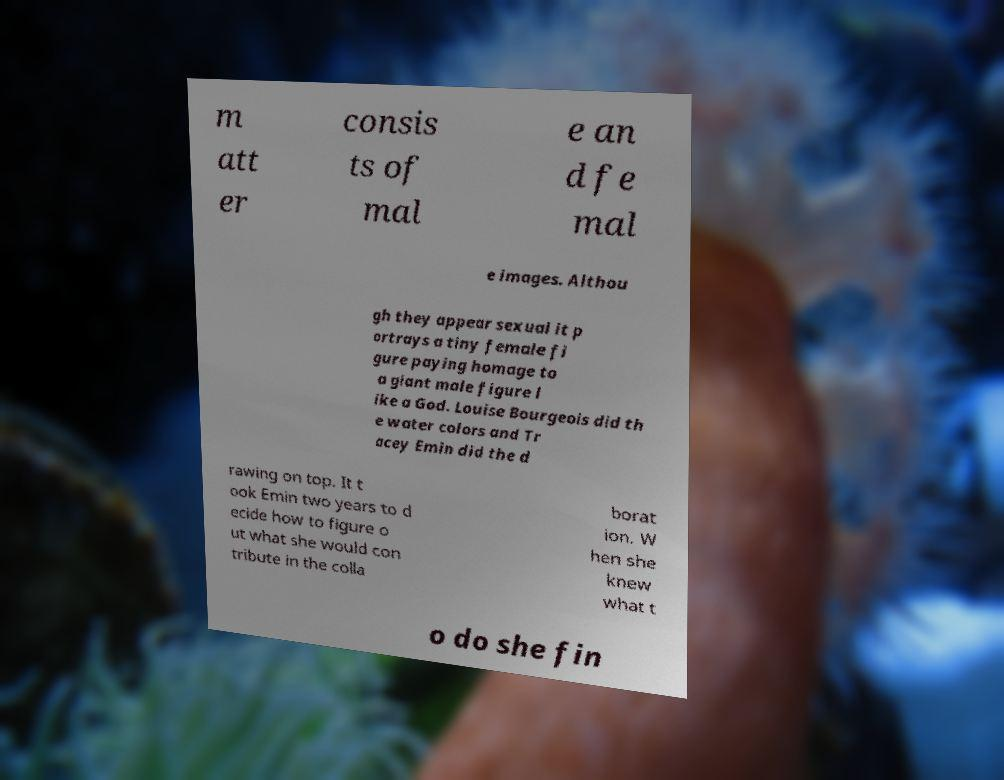I need the written content from this picture converted into text. Can you do that? m att er consis ts of mal e an d fe mal e images. Althou gh they appear sexual it p ortrays a tiny female fi gure paying homage to a giant male figure l ike a God. Louise Bourgeois did th e water colors and Tr acey Emin did the d rawing on top. It t ook Emin two years to d ecide how to figure o ut what she would con tribute in the colla borat ion. W hen she knew what t o do she fin 